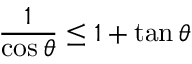Convert formula to latex. <formula><loc_0><loc_0><loc_500><loc_500>\frac { 1 } { \cos \theta } \leq 1 + \tan \theta</formula> 